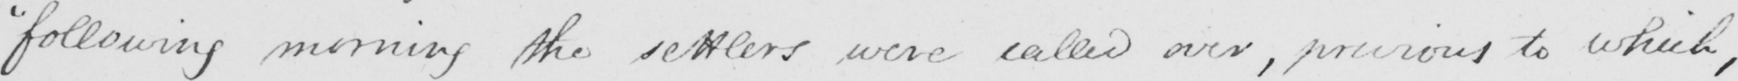Please provide the text content of this handwritten line. " following morning the settlers were called over , previous to which , 